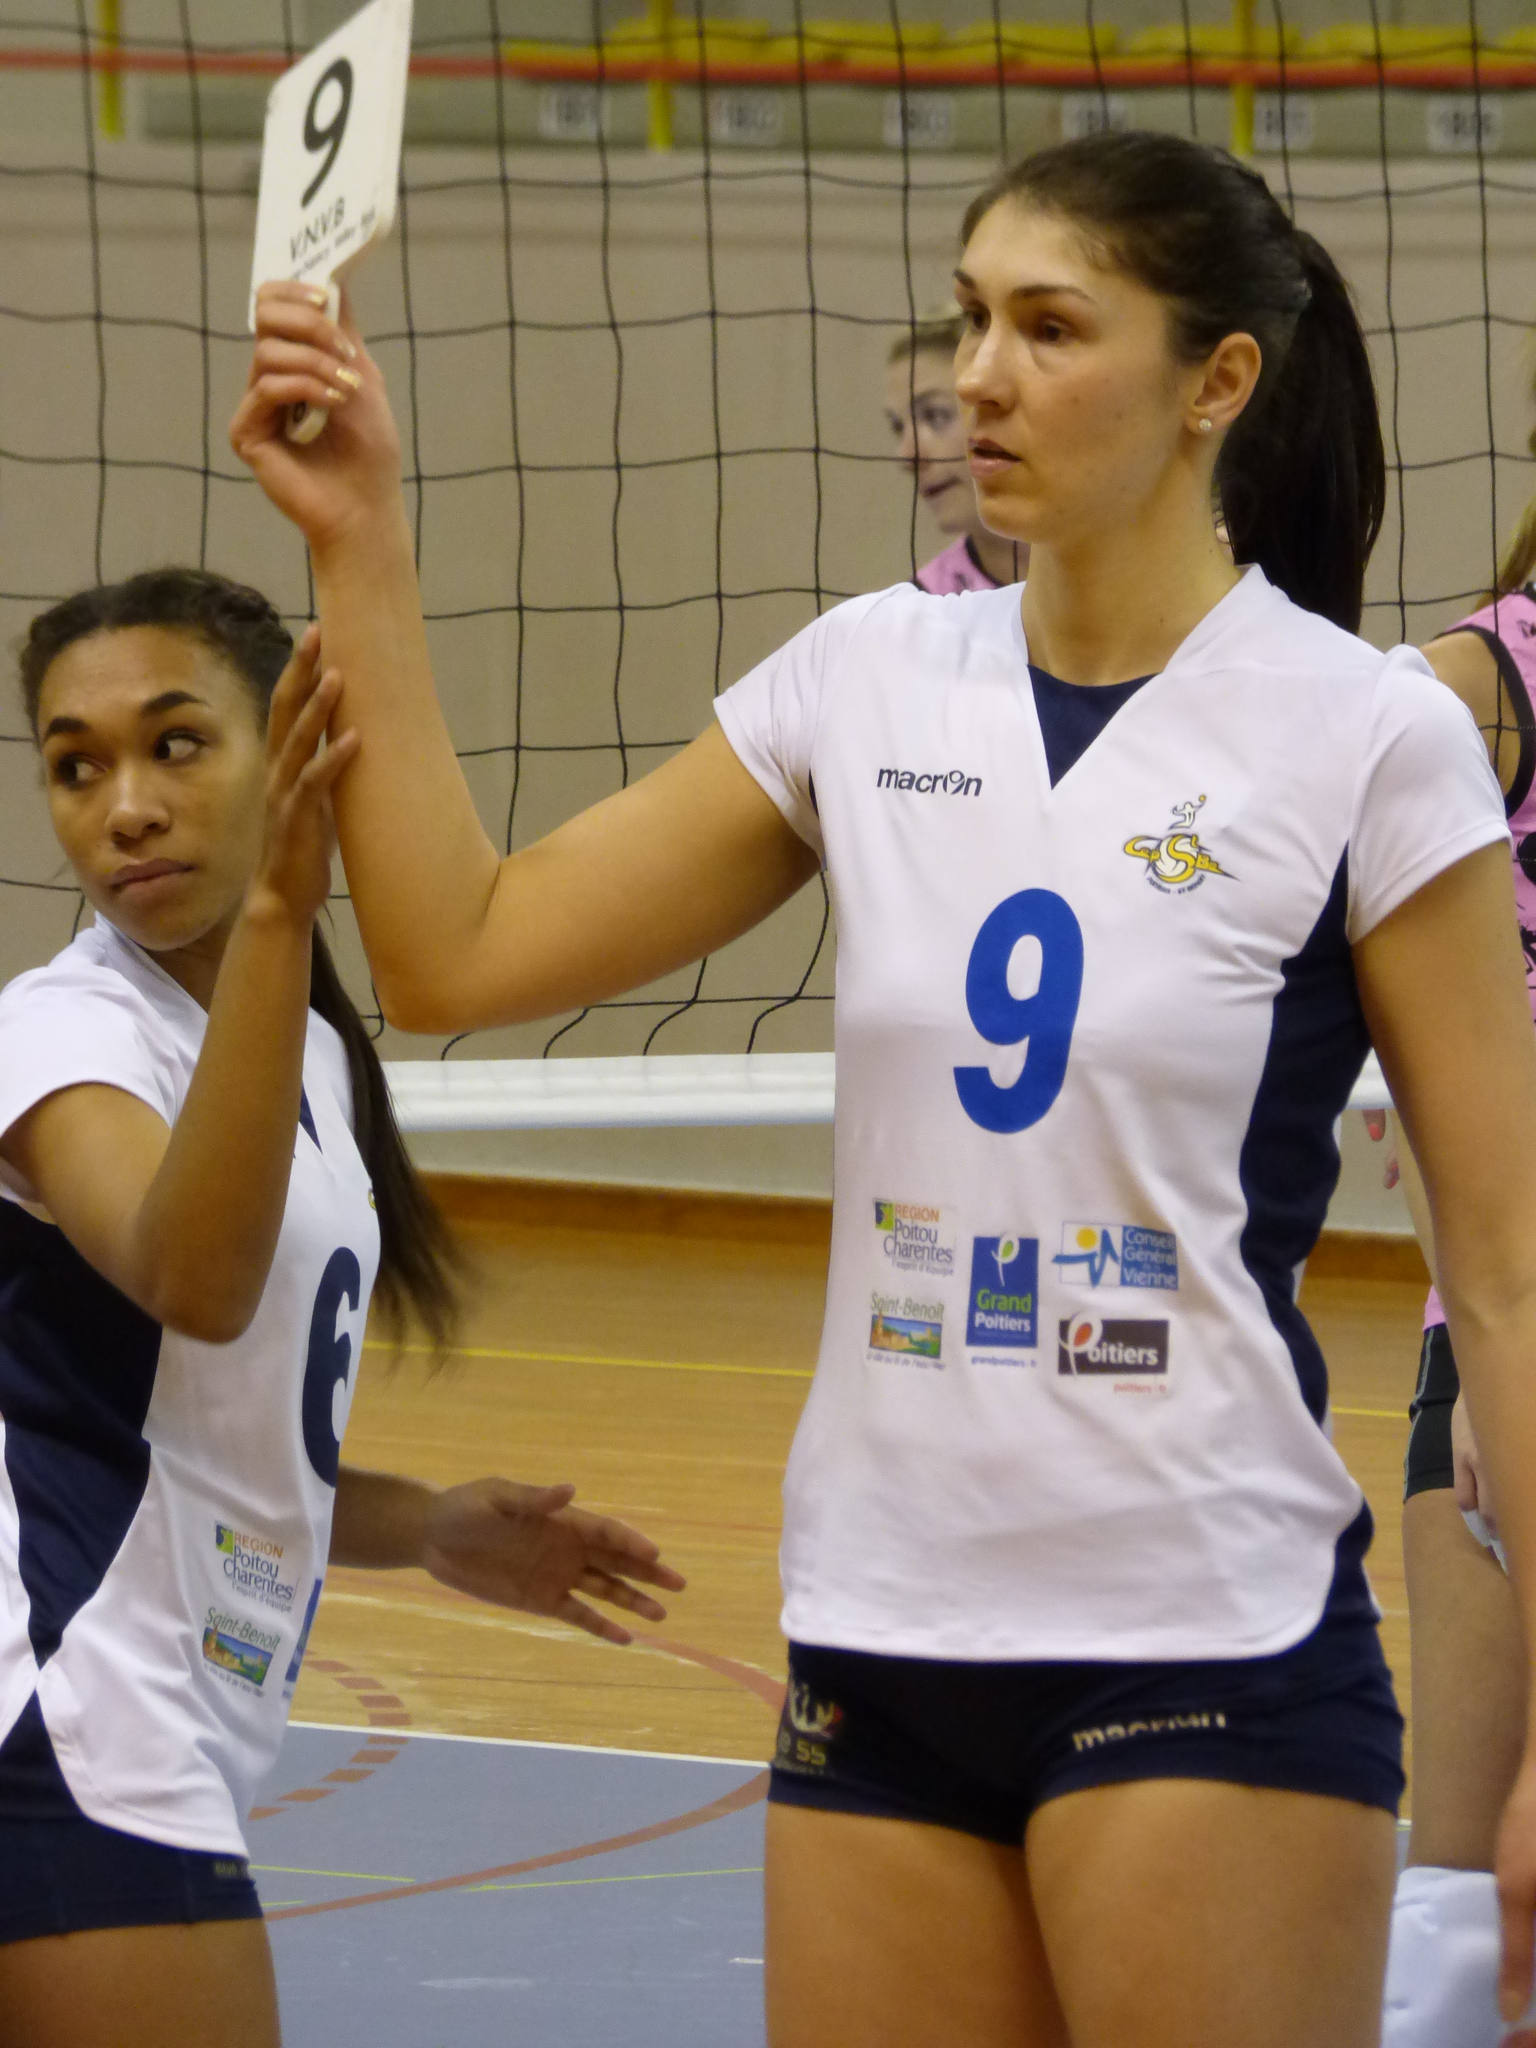<image>
Summarize the visual content of the image. Female athlete in a white uniform that has macron on the right side. 